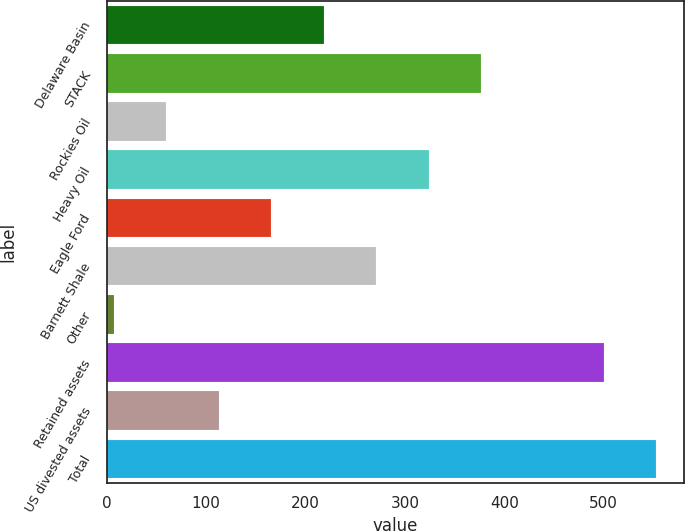Convert chart. <chart><loc_0><loc_0><loc_500><loc_500><bar_chart><fcel>Delaware Basin<fcel>STACK<fcel>Rockies Oil<fcel>Heavy Oil<fcel>Eagle Ford<fcel>Barnett Shale<fcel>Other<fcel>Retained assets<fcel>US divested assets<fcel>Total<nl><fcel>218.2<fcel>376.6<fcel>59.8<fcel>323.8<fcel>165.4<fcel>271<fcel>7<fcel>500<fcel>112.6<fcel>552.8<nl></chart> 